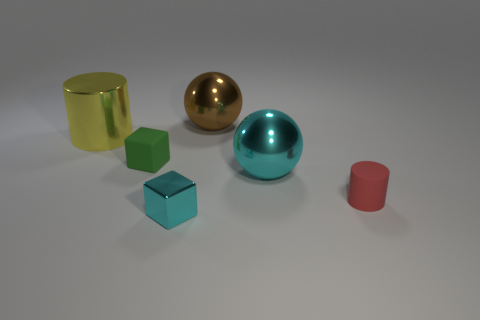Add 2 yellow cubes. How many objects exist? 8 Subtract all cylinders. How many objects are left? 4 Add 1 large green things. How many large green things exist? 1 Subtract 0 blue cylinders. How many objects are left? 6 Subtract all purple balls. Subtract all gray blocks. How many balls are left? 2 Subtract all balls. Subtract all small green matte blocks. How many objects are left? 3 Add 4 large shiny cylinders. How many large shiny cylinders are left? 5 